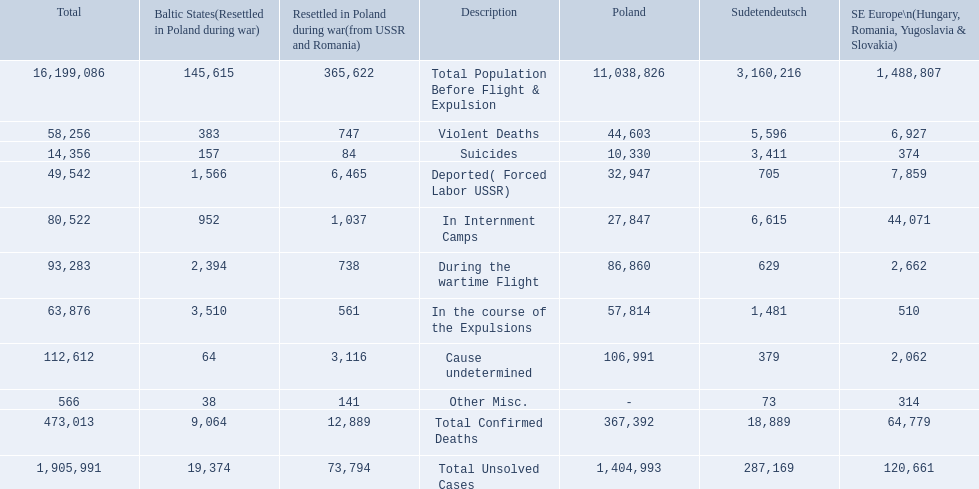What were all of the types of deaths? Violent Deaths, Suicides, Deported( Forced Labor USSR), In Internment Camps, During the wartime Flight, In the course of the Expulsions, Cause undetermined, Other Misc. And their totals in the baltic states? 383, 157, 1,566, 952, 2,394, 3,510, 64, 38. Were more deaths in the baltic states caused by undetermined causes or misc.? Cause undetermined. 